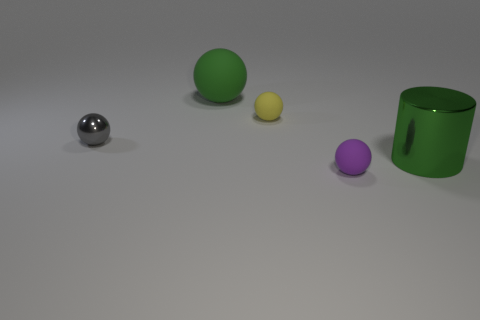Add 2 large rubber things. How many objects exist? 7 Subtract all spheres. How many objects are left? 1 Add 3 matte balls. How many matte balls exist? 6 Subtract 0 red cylinders. How many objects are left? 5 Subtract all matte objects. Subtract all large objects. How many objects are left? 0 Add 2 shiny cylinders. How many shiny cylinders are left? 3 